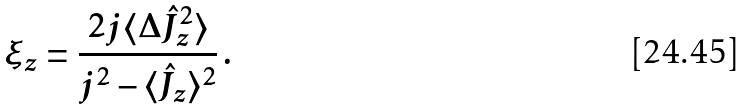<formula> <loc_0><loc_0><loc_500><loc_500>\xi _ { z } = \frac { 2 j \langle \Delta \hat { J } _ { z } ^ { 2 } \rangle } { j ^ { 2 } - \langle \hat { J } _ { z } \rangle ^ { 2 } } \, .</formula> 